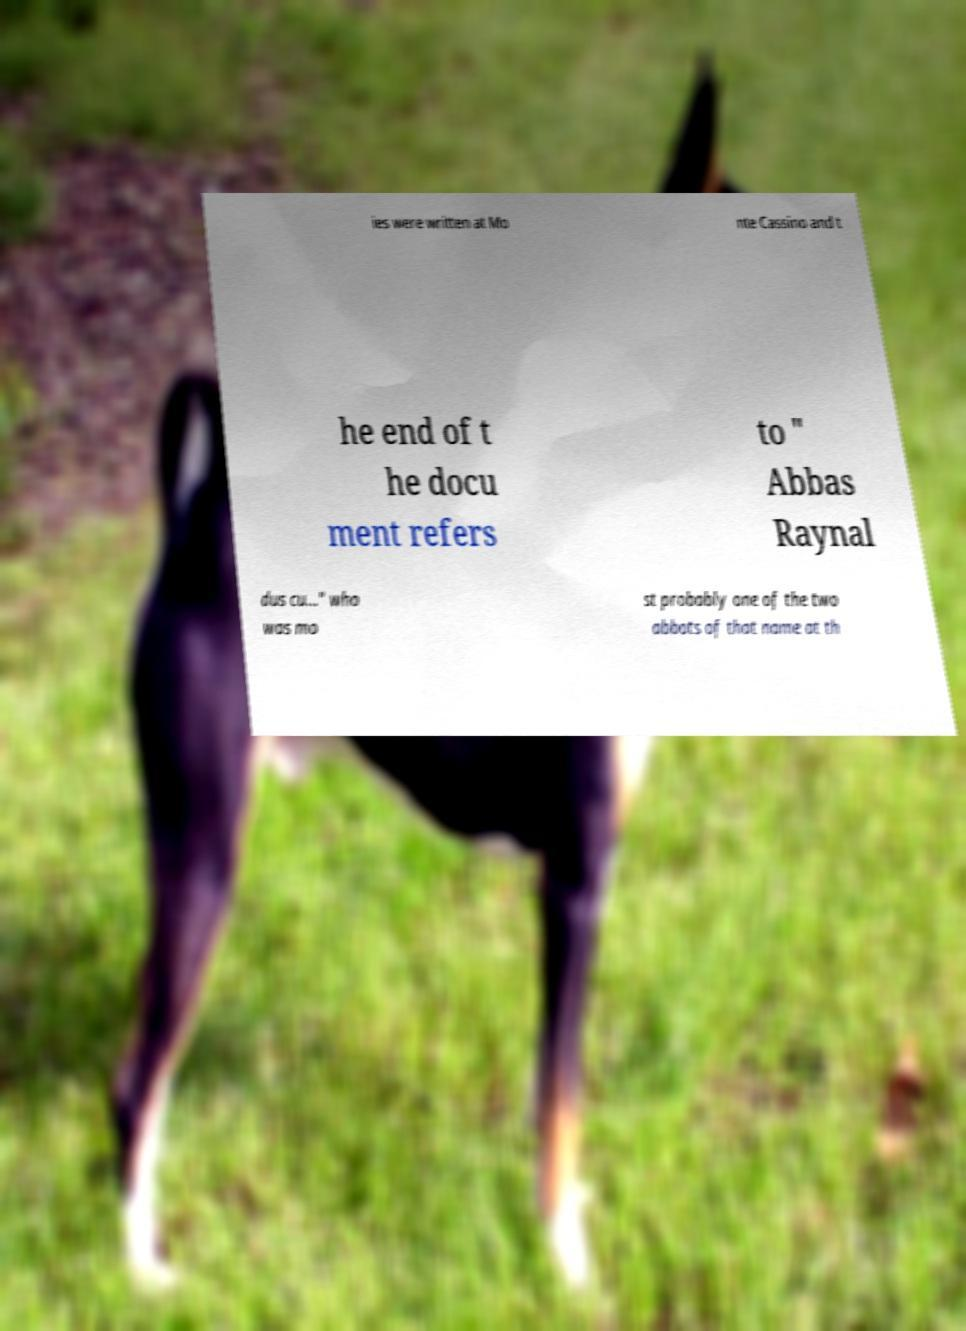Can you read and provide the text displayed in the image?This photo seems to have some interesting text. Can you extract and type it out for me? ies were written at Mo nte Cassino and t he end of t he docu ment refers to " Abbas Raynal dus cu..." who was mo st probably one of the two abbots of that name at th 